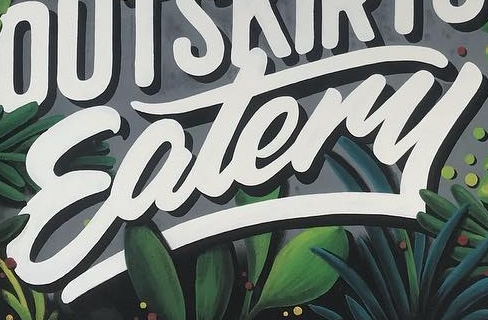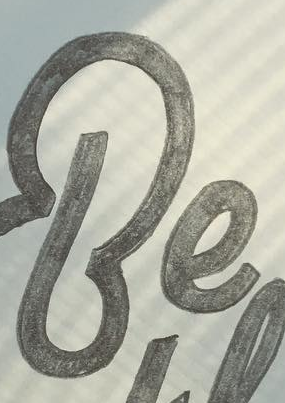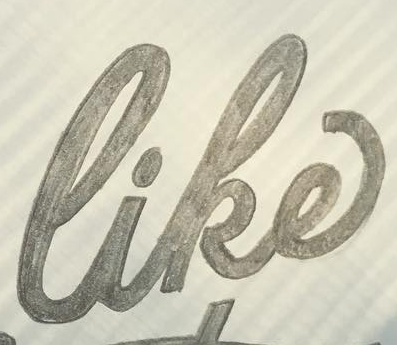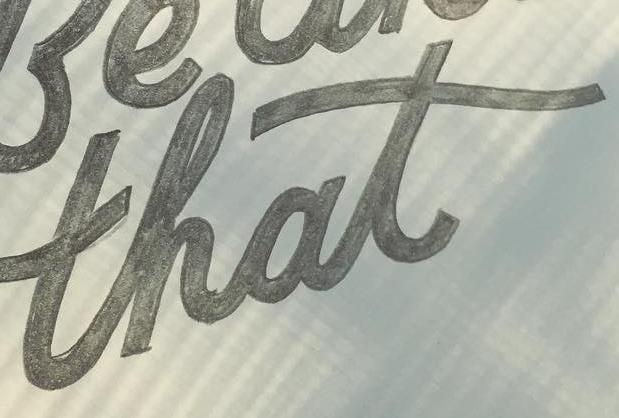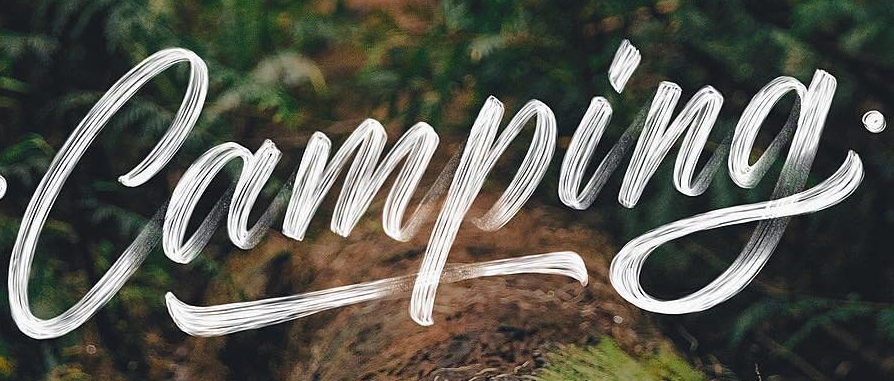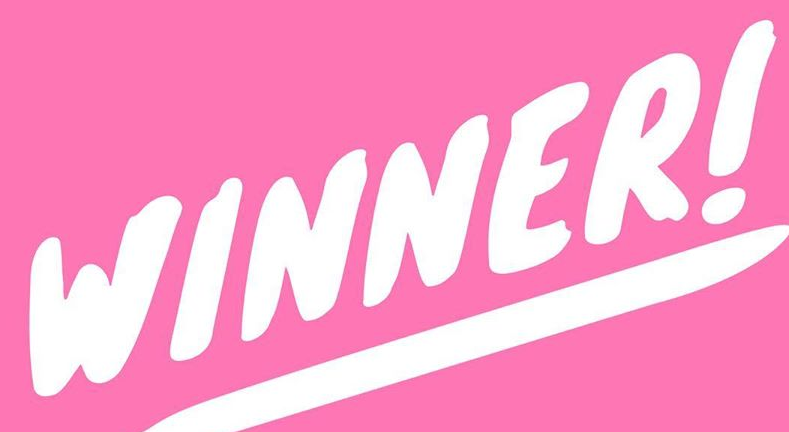Read the text content from these images in order, separated by a semicolon. Eatery; Be; like; that; Camping; WINNER! 